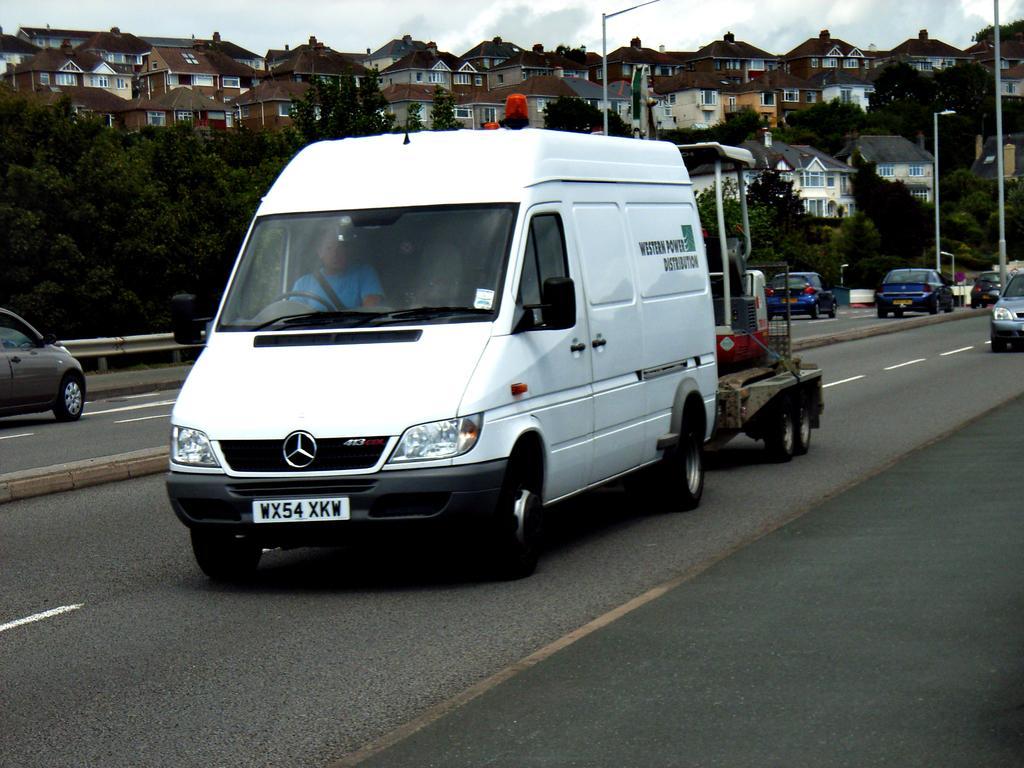How would you summarize this image in a sentence or two? In this picture we can see few vehicles are moving on the road, side we can see some houses and trees. 